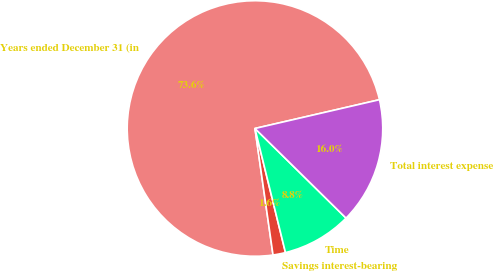Convert chart to OTSL. <chart><loc_0><loc_0><loc_500><loc_500><pie_chart><fcel>Years ended December 31 (in<fcel>Savings interest-bearing<fcel>Time<fcel>Total interest expense<nl><fcel>73.64%<fcel>1.58%<fcel>8.79%<fcel>15.99%<nl></chart> 